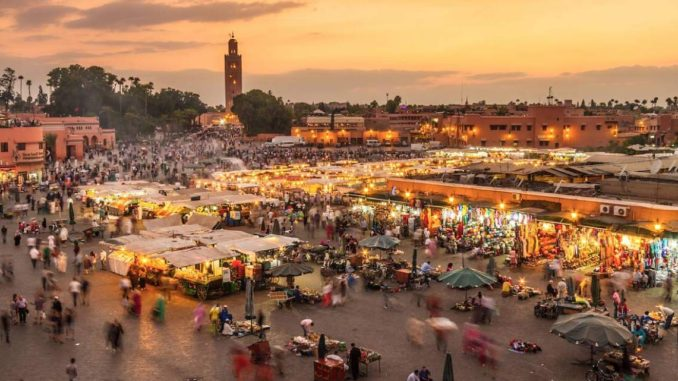Describe the atmosphere in the marketplace during the sunset. The atmosphere in the marketplace during sunset is electrifying and vibrant. As the sun sets, the daylight transitions to a warm amber hue that spreads across the square, creating a magical glow over all the activity. People seem to be more animated, with the coolness of the evening setting in, invigorating the bustling activities. Vendors enthusiastically engage with passersby, showcasing their goods with renewed energy. The mixed aromas of sizzling street food, spices, and exotic perfumes blend in the air, adding another layer to the sensory experience. The chatter of the crowd grows louder, punctuated by laughter and the occasional music from street performers, enveloping everyone in a festive mood. 